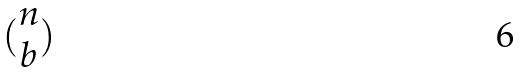<formula> <loc_0><loc_0><loc_500><loc_500>( \begin{matrix} n \\ b \end{matrix} )</formula> 